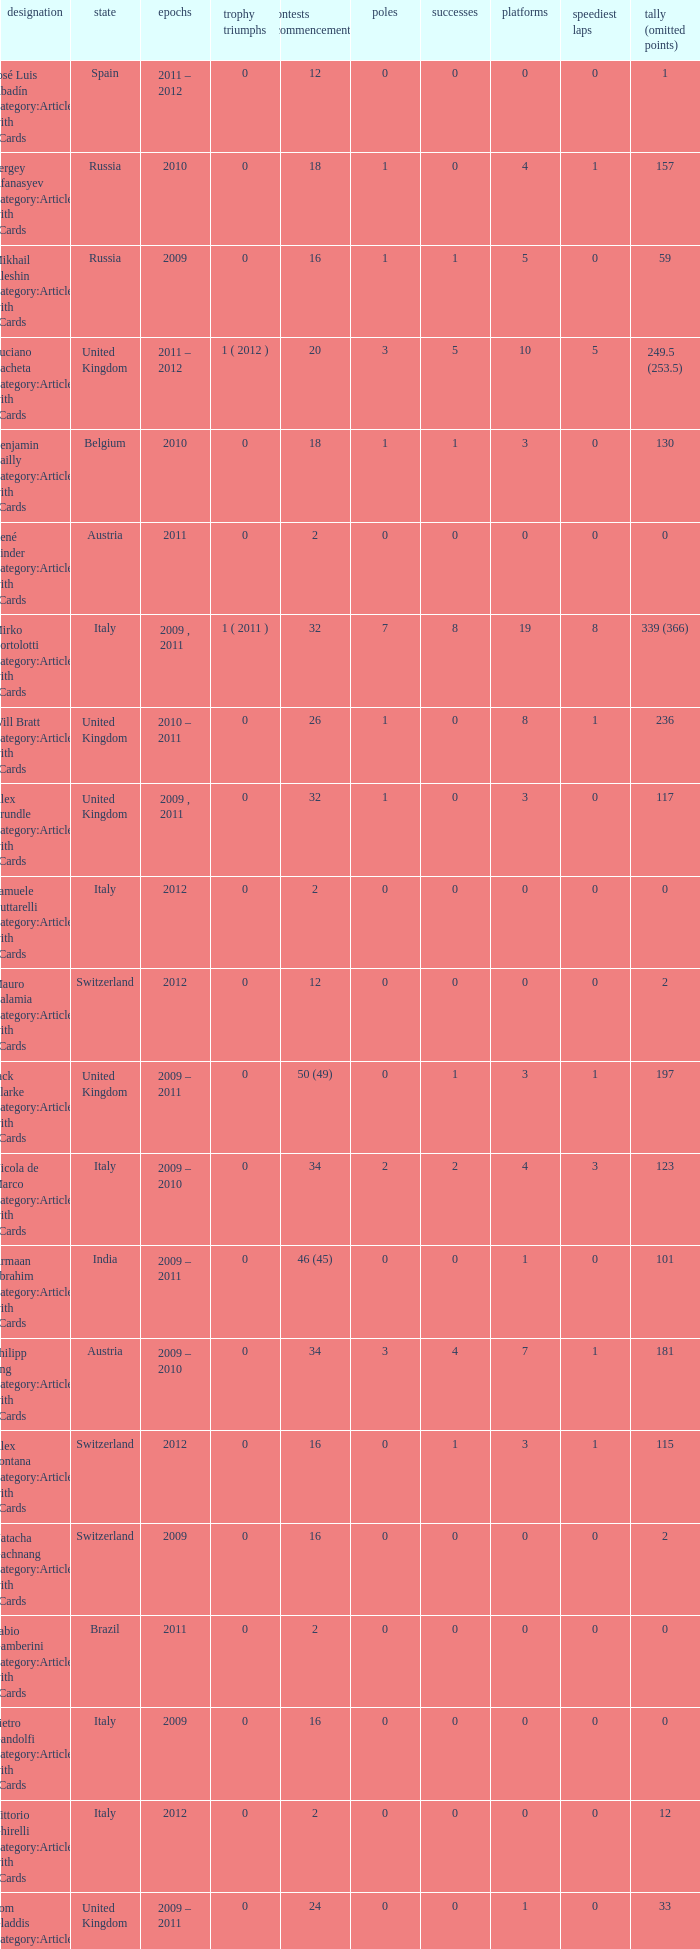What were the starts when the points dropped 18? 8.0. 